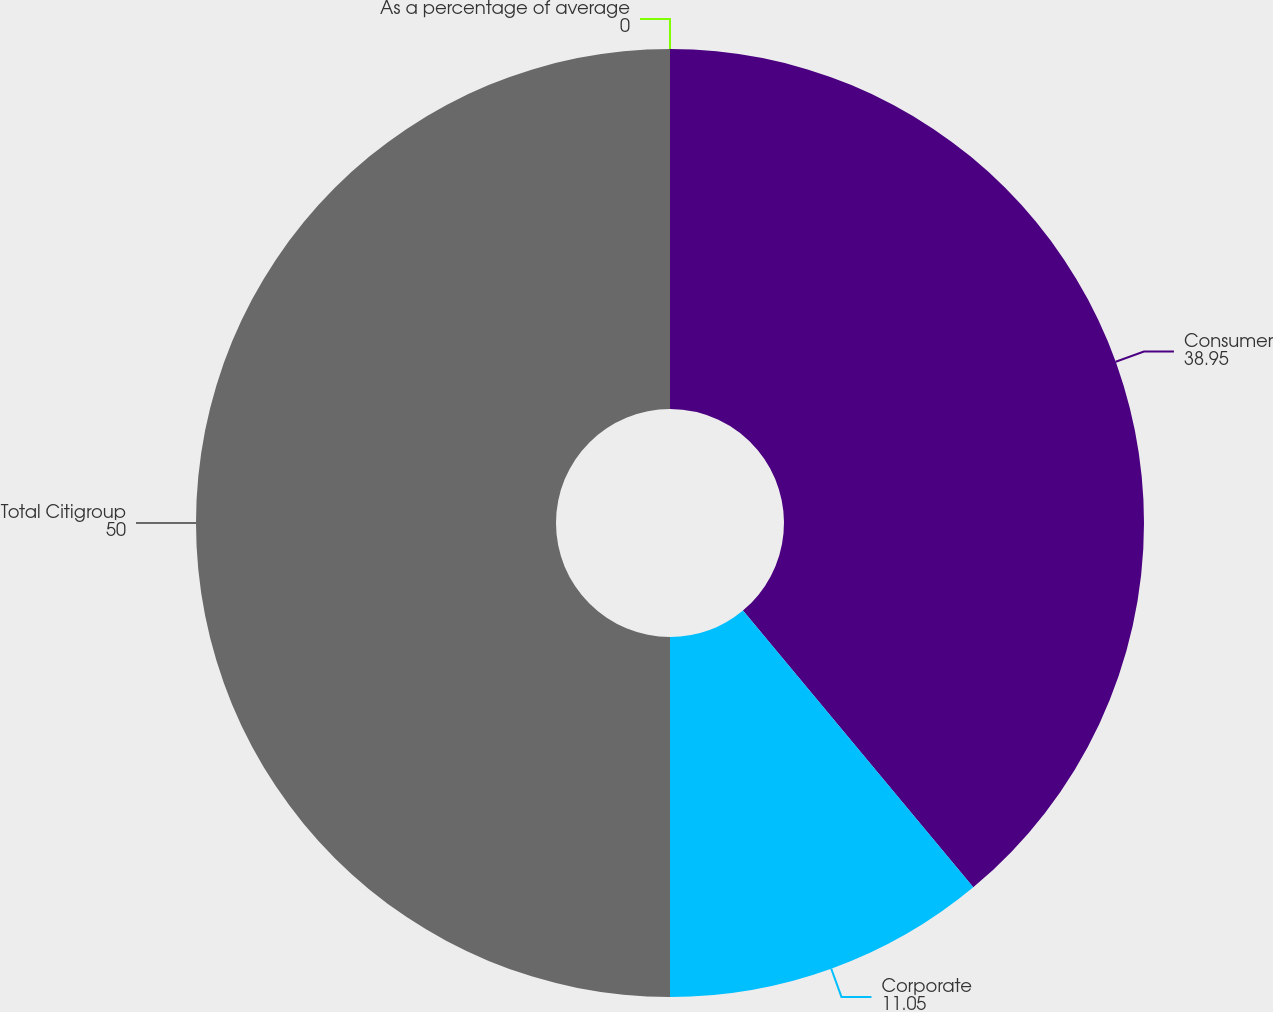<chart> <loc_0><loc_0><loc_500><loc_500><pie_chart><fcel>As a percentage of average<fcel>Consumer<fcel>Corporate<fcel>Total Citigroup<nl><fcel>0.0%<fcel>38.95%<fcel>11.05%<fcel>50.0%<nl></chart> 